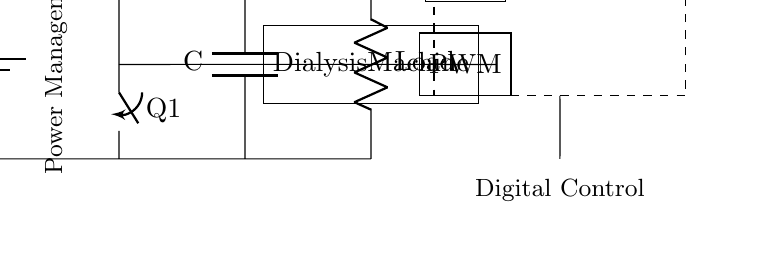What component is used to regulate voltage? The buck converter is responsible for regulating the voltage in the circuit. It steps down the input voltage to a lower output voltage that is suitable for the load.
Answer: Buck converter What is the function of the microcontroller in this circuit? The microcontroller manages the control logic, which includes reading sensor inputs and controlling the PWM signal for the buck converter. It plays a crucial role in digital control for efficient power delivery.
Answer: Control logic What is the load in the circuit? The load in the circuit is specified as the dialysis machine, which is the component that consumes power. It is designed to receive the regulated output from the buck converter.
Answer: Dialysis machine What is the type of power conversion taking place in this circuit? The circuit employs a buck converter, which is a type of DC-DC converter that steps down voltage. This indicates that the conversion process is delivering lower voltage to the load compared to the input voltage.
Answer: DC-DC conversion How many main components are there in the circuit diagram? The main components of the circuit include the power supply, buck converter, microcontroller, ADC, PWM, capacitor, and the load. Counting all distinct components gives a total of six main components.
Answer: Six What does PWM stand for and what is its role here? PWM stands for Pulse Width Modulation. In this circuit, it is used to control the output voltage of the buck converter by varying the width of the pulses applied to the converter, which adjusts the average voltage delivered to the load.
Answer: Pulse Width Modulation What is connected to the output of the ADC? The ADC (analog-to-digital converter) is connected to the microcontroller. Its role is to convert the analog signals from the load or sensors into digital signals that can be processed by the microcontroller.
Answer: Microcontroller 